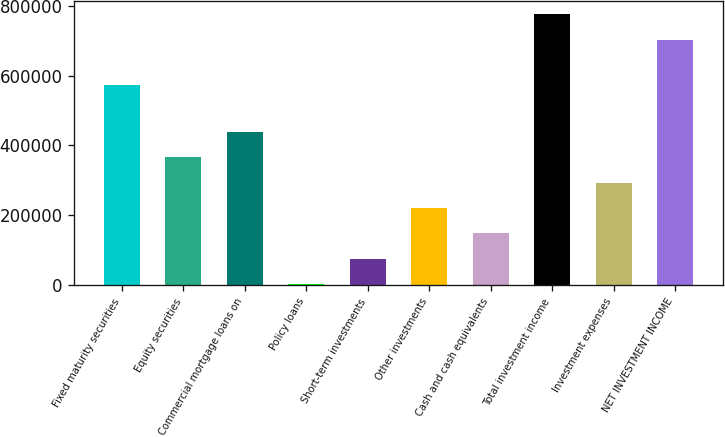Convert chart. <chart><loc_0><loc_0><loc_500><loc_500><bar_chart><fcel>Fixed maturity securities<fcel>Equity securities<fcel>Commercial mortgage loans on<fcel>Policy loans<fcel>Short-term investments<fcel>Other investments<fcel>Cash and cash equivalents<fcel>Total investment income<fcel>Investment expenses<fcel>NET INVESTMENT INCOME<nl><fcel>572909<fcel>366009<fcel>438561<fcel>3248<fcel>75800.2<fcel>220905<fcel>148352<fcel>775742<fcel>293457<fcel>703190<nl></chart> 